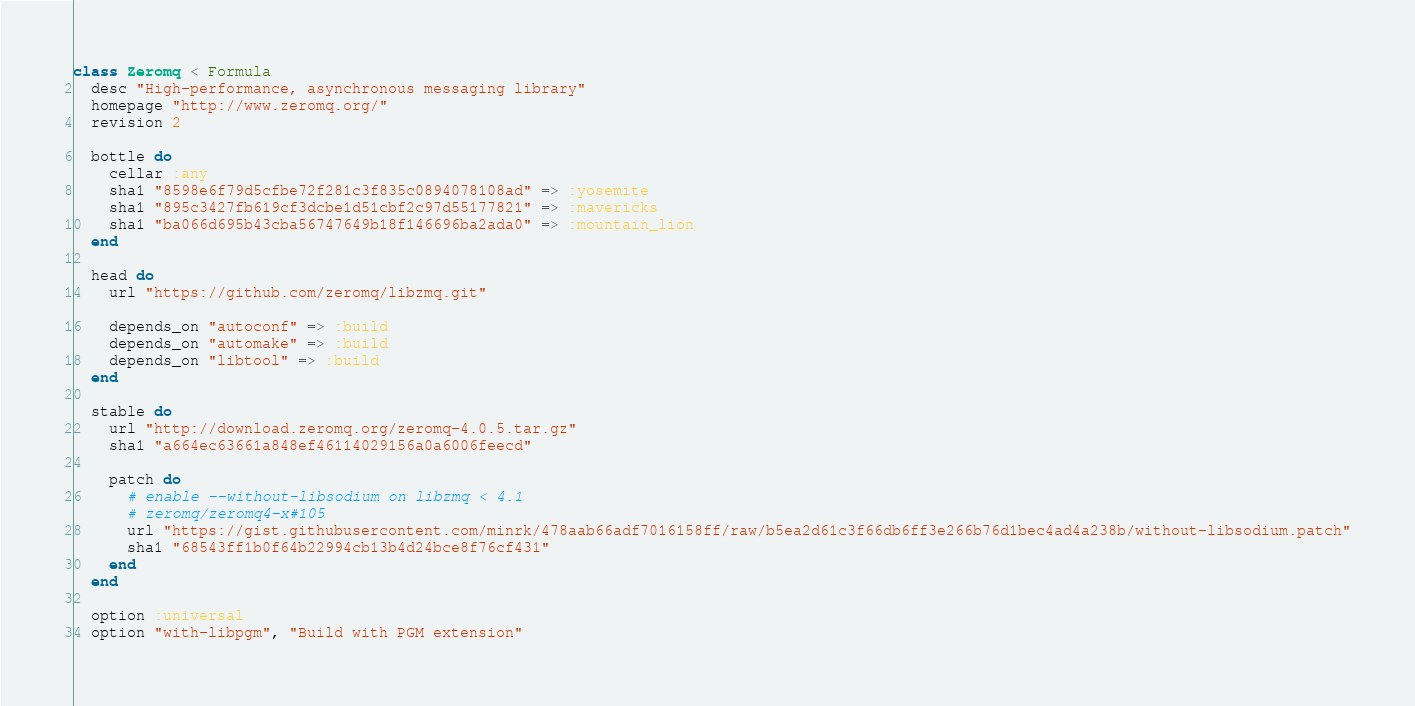Convert code to text. <code><loc_0><loc_0><loc_500><loc_500><_Ruby_>class Zeromq < Formula
  desc "High-performance, asynchronous messaging library"
  homepage "http://www.zeromq.org/"
  revision 2

  bottle do
    cellar :any
    sha1 "8598e6f79d5cfbe72f281c3f835c0894078108ad" => :yosemite
    sha1 "895c3427fb619cf3dcbe1d51cbf2c97d55177821" => :mavericks
    sha1 "ba066d695b43cba56747649b18f146696ba2ada0" => :mountain_lion
  end

  head do
    url "https://github.com/zeromq/libzmq.git"

    depends_on "autoconf" => :build
    depends_on "automake" => :build
    depends_on "libtool" => :build
  end

  stable do
    url "http://download.zeromq.org/zeromq-4.0.5.tar.gz"
    sha1 "a664ec63661a848ef46114029156a0a6006feecd"

    patch do
      # enable --without-libsodium on libzmq < 4.1
      # zeromq/zeromq4-x#105
      url "https://gist.githubusercontent.com/minrk/478aab66adf7016158ff/raw/b5ea2d61c3f66db6ff3e266b76d1bec4ad4a238b/without-libsodium.patch"
      sha1 "68543ff1b0f64b22994cb13b4d24bce8f76cf431"
    end
  end

  option :universal
  option "with-libpgm", "Build with PGM extension"
</code> 